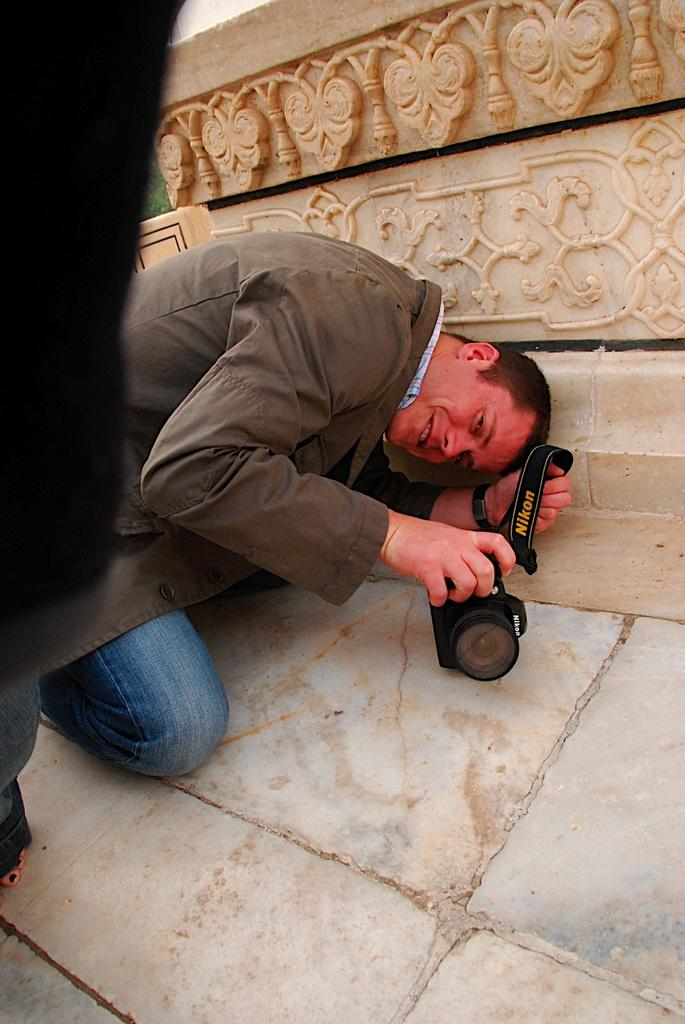What is the position of the person in the image? The person is in a kneeling position on the ground. What is the person holding in their hand? The person is holding a camera in their hand. How is the person holding the camera? The person is holding the camera at a certain angle. What is the facial expression of the person in the image? The person is smiling. What type of liquid is being poured from the carriage in the image? There is no carriage or liquid present in the image. What type of plough is being used by the person in the image? There is no plough present in the image. 